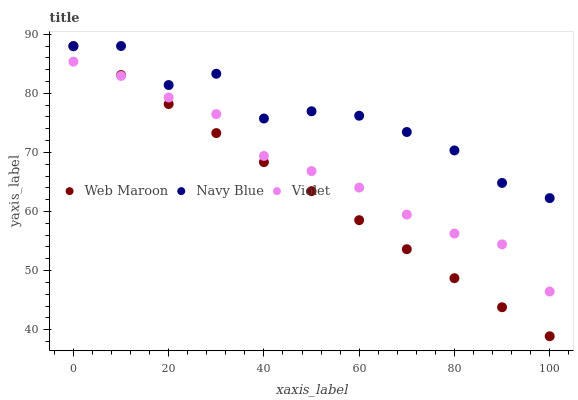Does Web Maroon have the minimum area under the curve?
Answer yes or no. Yes. Does Navy Blue have the maximum area under the curve?
Answer yes or no. Yes. Does Violet have the minimum area under the curve?
Answer yes or no. No. Does Violet have the maximum area under the curve?
Answer yes or no. No. Is Web Maroon the smoothest?
Answer yes or no. Yes. Is Navy Blue the roughest?
Answer yes or no. Yes. Is Violet the smoothest?
Answer yes or no. No. Is Violet the roughest?
Answer yes or no. No. Does Web Maroon have the lowest value?
Answer yes or no. Yes. Does Violet have the lowest value?
Answer yes or no. No. Does Web Maroon have the highest value?
Answer yes or no. Yes. Does Violet have the highest value?
Answer yes or no. No. Is Violet less than Navy Blue?
Answer yes or no. Yes. Is Navy Blue greater than Violet?
Answer yes or no. Yes. Does Web Maroon intersect Violet?
Answer yes or no. Yes. Is Web Maroon less than Violet?
Answer yes or no. No. Is Web Maroon greater than Violet?
Answer yes or no. No. Does Violet intersect Navy Blue?
Answer yes or no. No. 